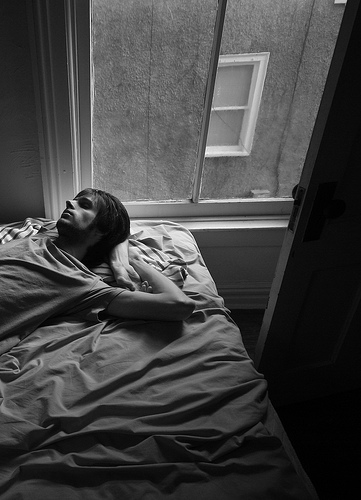Are the floor and the door made of the sharegpt4v/same material? Yes, the floor and the door appear to be made of the sharegpt4v/same material. 